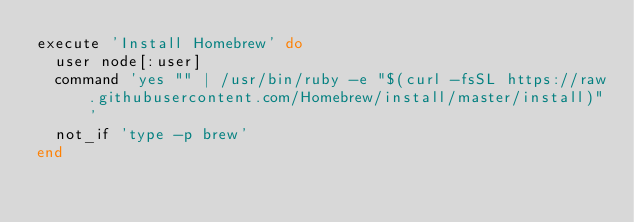Convert code to text. <code><loc_0><loc_0><loc_500><loc_500><_Ruby_>execute 'Install Homebrew' do
  user node[:user]
  command 'yes "" | /usr/bin/ruby -e "$(curl -fsSL https://raw.githubusercontent.com/Homebrew/install/master/install)"'
  not_if 'type -p brew'
end
</code> 